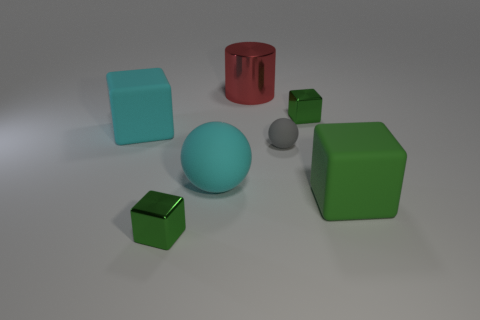Subtract all green blocks. How many were subtracted if there are1green blocks left? 2 Subtract all brown balls. How many green cubes are left? 3 Add 3 small brown matte things. How many objects exist? 10 Subtract all blocks. How many objects are left? 3 Subtract 0 brown cubes. How many objects are left? 7 Subtract all spheres. Subtract all cyan rubber spheres. How many objects are left? 4 Add 5 big cylinders. How many big cylinders are left? 6 Add 1 tiny blue matte things. How many tiny blue matte things exist? 1 